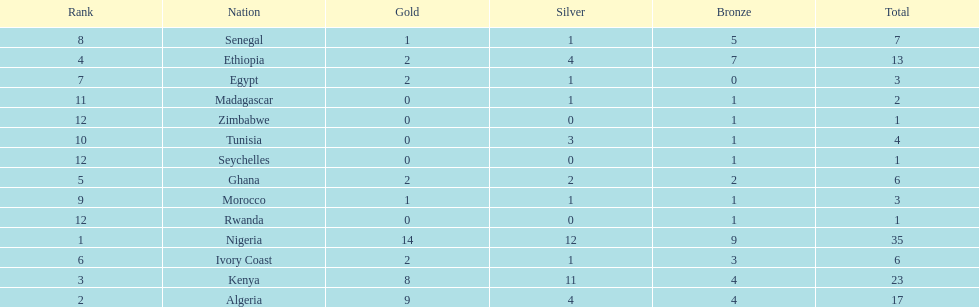The team with the most gold medals Nigeria. 